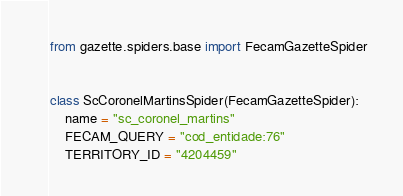Convert code to text. <code><loc_0><loc_0><loc_500><loc_500><_Python_>from gazette.spiders.base import FecamGazetteSpider


class ScCoronelMartinsSpider(FecamGazetteSpider):
    name = "sc_coronel_martins"
    FECAM_QUERY = "cod_entidade:76"
    TERRITORY_ID = "4204459"
</code> 